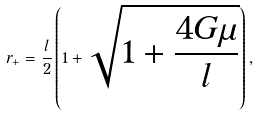Convert formula to latex. <formula><loc_0><loc_0><loc_500><loc_500>r _ { + } = \frac { l } { 2 } \left ( 1 + \sqrt { 1 + \frac { 4 G \mu } { l } } \right ) ,</formula> 